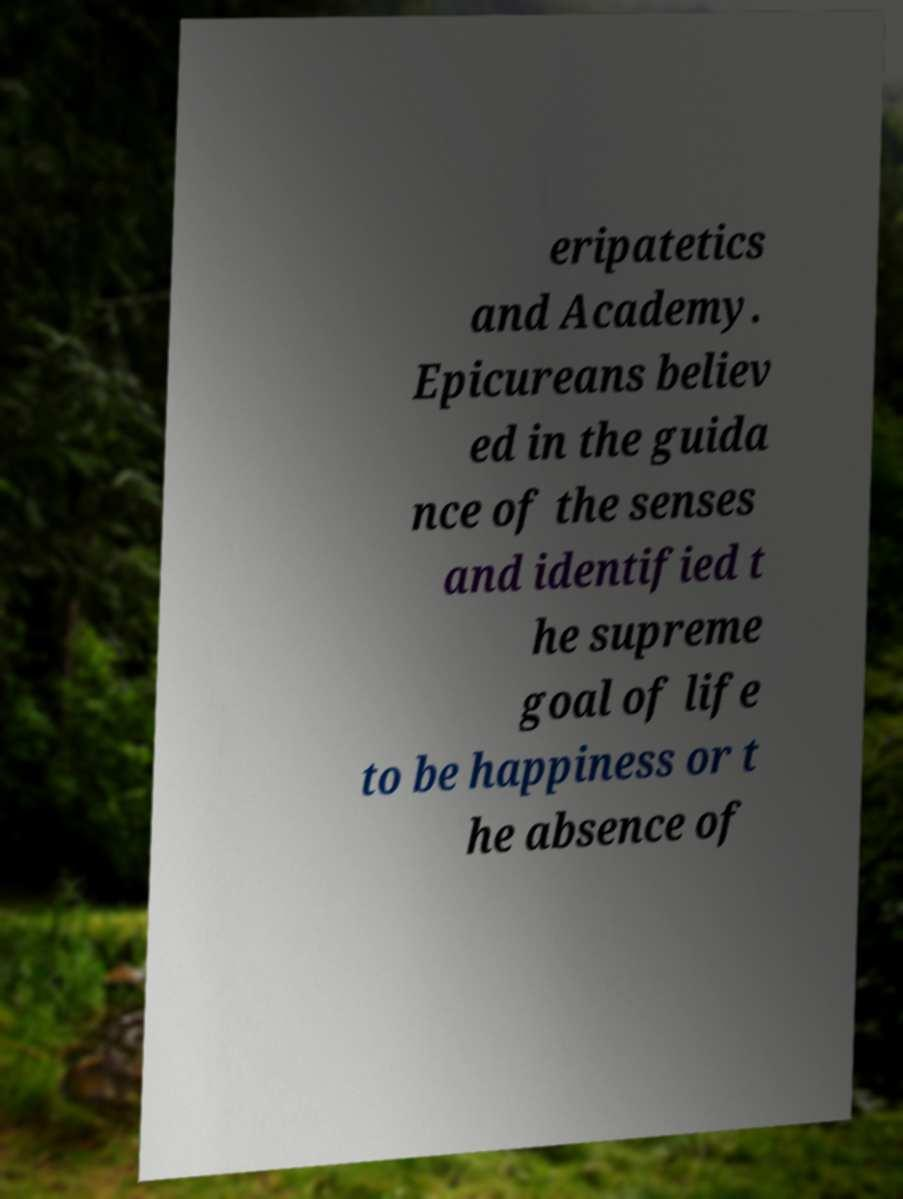Please identify and transcribe the text found in this image. eripatetics and Academy. Epicureans believ ed in the guida nce of the senses and identified t he supreme goal of life to be happiness or t he absence of 